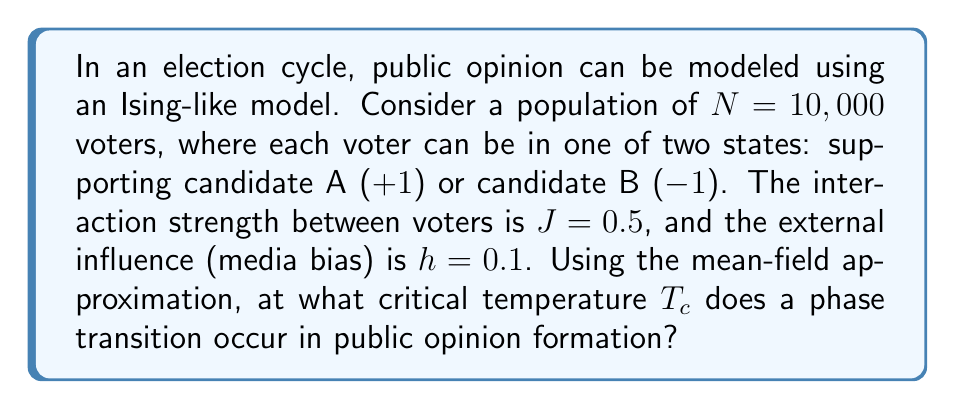Can you solve this math problem? To solve this problem, we'll use the mean-field approximation of the Ising model applied to public opinion formation:

1. In the mean-field theory, the critical temperature $T_c$ is given by:

   $$T_c = zJ$$

   where $z$ is the number of nearest neighbors and $J$ is the interaction strength.

2. In a fully connected network (which we assume for simplicity in public opinion models), each voter interacts with all other voters. So, $z = N - 1 \approx N$ for large $N$.

3. Given:
   - $N = 10,000$
   - $J = 0.5$

4. Substituting these values into the critical temperature equation:

   $$T_c = N \cdot J = 10,000 \cdot 0.5 = 5,000$$

5. Note that this temperature is in arbitrary units. In the context of public opinion, it represents the social temperature or the level of randomness in individual opinions.

6. The external field $h$ (media bias) doesn't affect the critical temperature but influences the direction of magnetization (overall opinion) below $T_c$.

7. At temperatures above $T_c$, public opinion will be disordered (no clear majority). Below $T_c$, a spontaneous magnetization occurs, representing a clear majority opinion forming.
Answer: $T_c = 5,000$ 